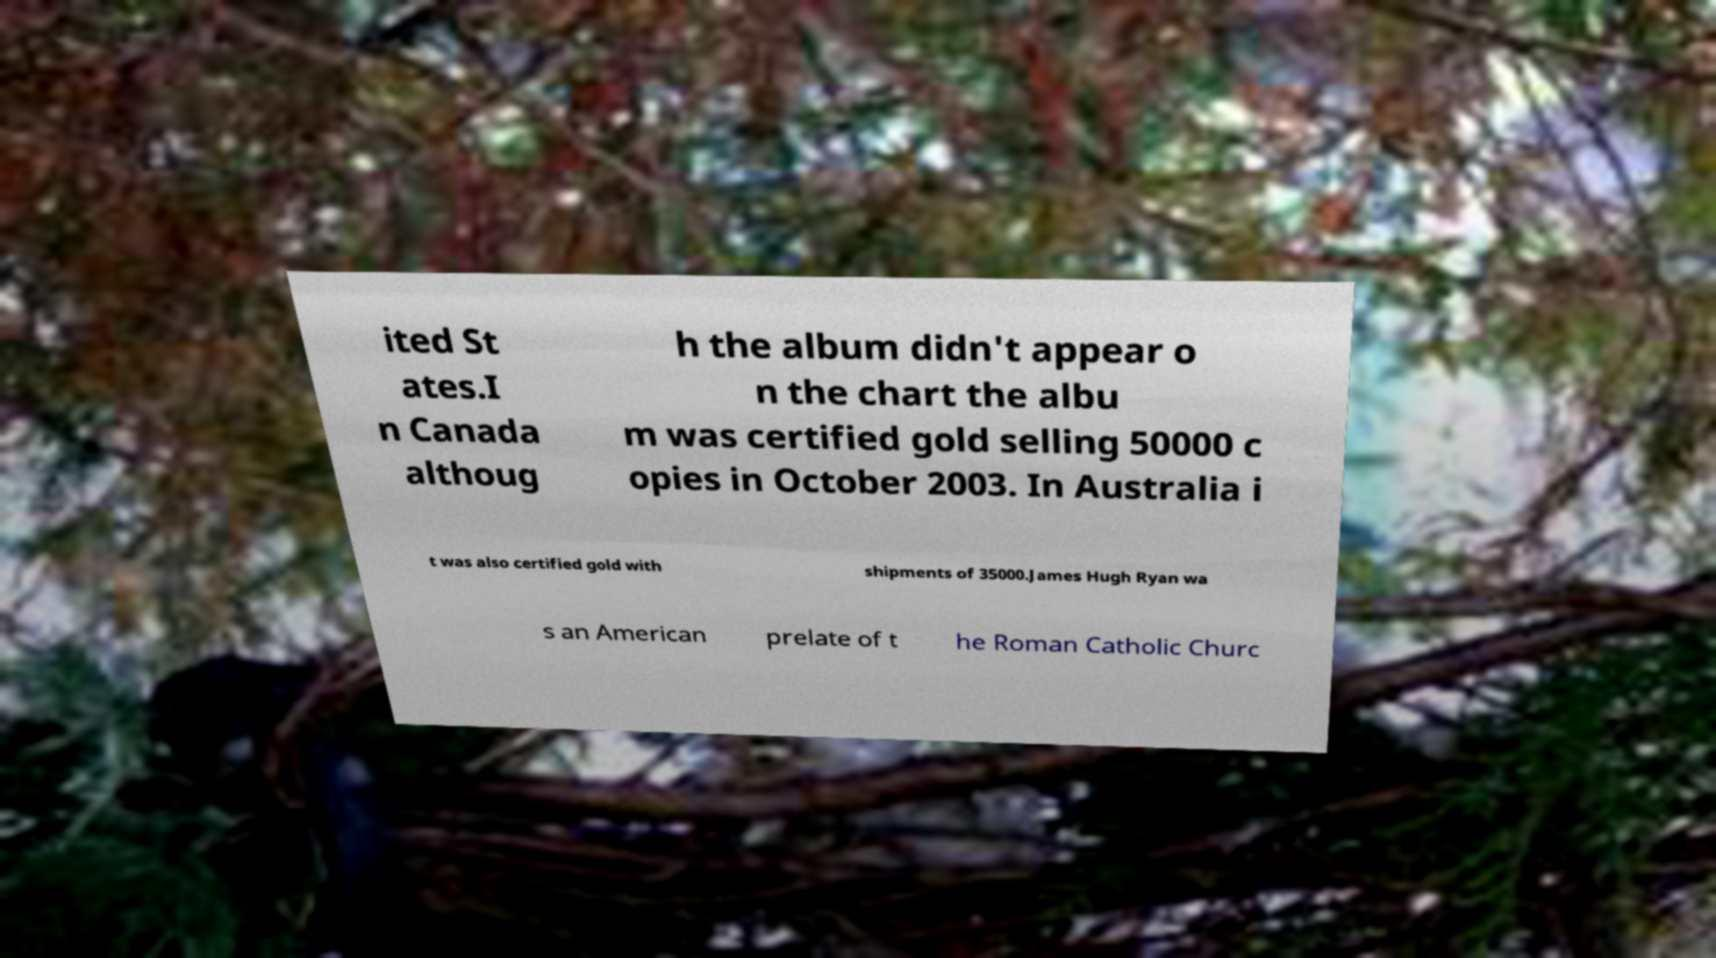I need the written content from this picture converted into text. Can you do that? ited St ates.I n Canada althoug h the album didn't appear o n the chart the albu m was certified gold selling 50000 c opies in October 2003. In Australia i t was also certified gold with shipments of 35000.James Hugh Ryan wa s an American prelate of t he Roman Catholic Churc 